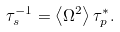Convert formula to latex. <formula><loc_0><loc_0><loc_500><loc_500>\tau _ { s } ^ { - 1 } = \left < \Omega ^ { 2 } \right > \tau _ { p } ^ { \ast } .</formula> 